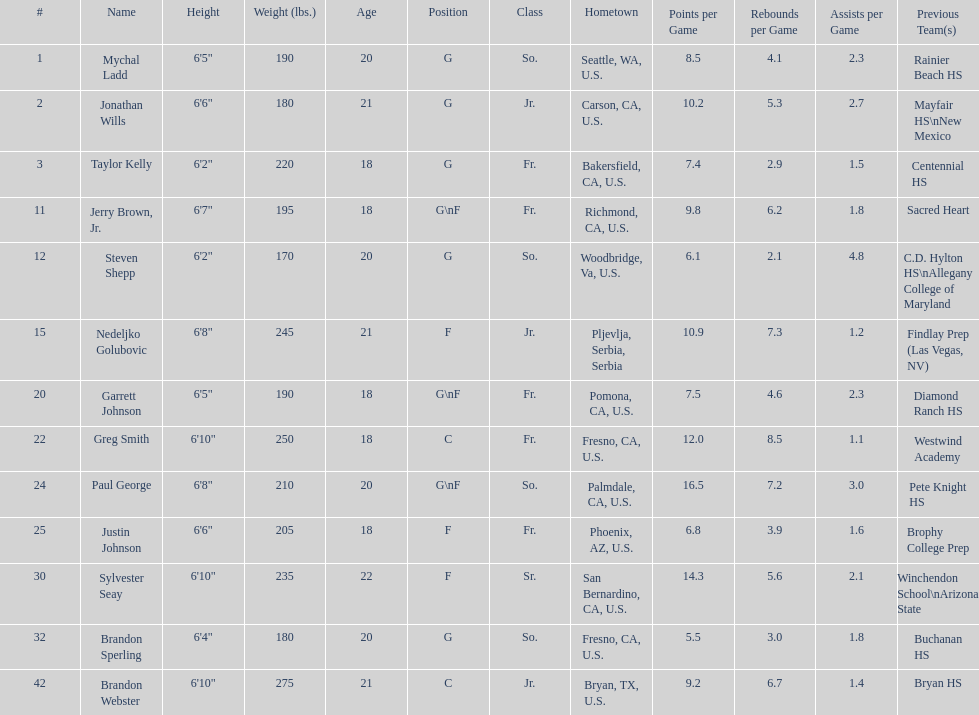Which player is taller, paul george or greg smith? Greg Smith. 